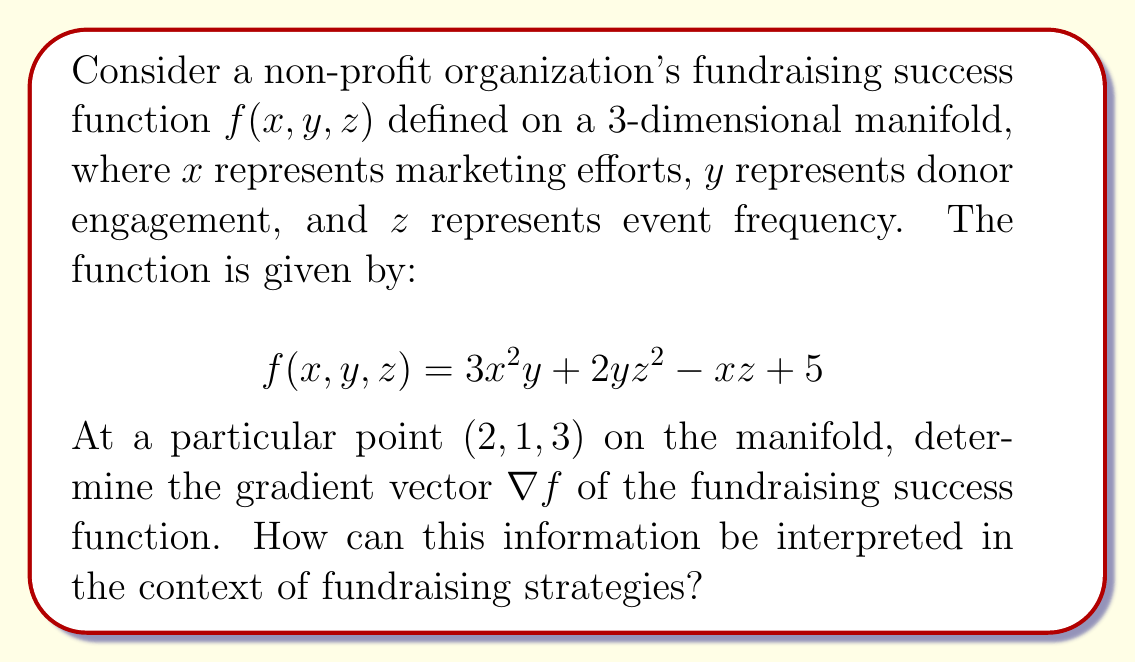Teach me how to tackle this problem. To solve this problem, we need to follow these steps:

1) The gradient of a function $f(x, y, z)$ is defined as:

   $$\nabla f = \left(\frac{\partial f}{\partial x}, \frac{\partial f}{\partial y}, \frac{\partial f}{\partial z}\right)$$

2) Let's calculate each partial derivative:

   $\frac{\partial f}{\partial x} = 6xy - z$
   
   $\frac{\partial f}{\partial y} = 3x^2 + 2z^2$
   
   $\frac{\partial f}{\partial z} = 4yz - x$

3) Now, we need to evaluate these at the point (2, 1, 3):

   $\frac{\partial f}{\partial x}|_{(2,1,3)} = 6(2)(1) - 3 = 9$
   
   $\frac{\partial f}{\partial y}|_{(2,1,3)} = 3(2^2) + 2(3^2) = 12 + 18 = 30$
   
   $\frac{\partial f}{\partial z}|_{(2,1,3)} = 4(1)(3) - 2 = 10$

4) Therefore, the gradient vector at (2, 1, 3) is:

   $$\nabla f|_{(2,1,3)} = (9, 30, 10)$$

Interpretation: The gradient vector indicates the direction of steepest increase in the fundraising success function at the given point. The magnitude of each component suggests the relative impact of changing that variable:

- The largest component is 30, corresponding to $y$ (donor engagement), suggesting that increasing donor engagement would have the most significant positive impact on fundraising success.
- The second largest component is 10, corresponding to $z$ (event frequency), indicating that increasing event frequency would also have a substantial positive impact.
- The smallest component is 9, corresponding to $x$ (marketing efforts), suggesting that while increasing marketing efforts would improve fundraising success, it may have less impact than the other two factors at this particular point.
Answer: The gradient vector of the fundraising success function at the point (2, 1, 3) is:

$$\nabla f|_{(2,1,3)} = (9, 30, 10)$$

This suggests that, at this point, focusing on increasing donor engagement would likely yield the highest return on investment for fundraising efforts, followed by increasing event frequency, and then marketing efforts. 